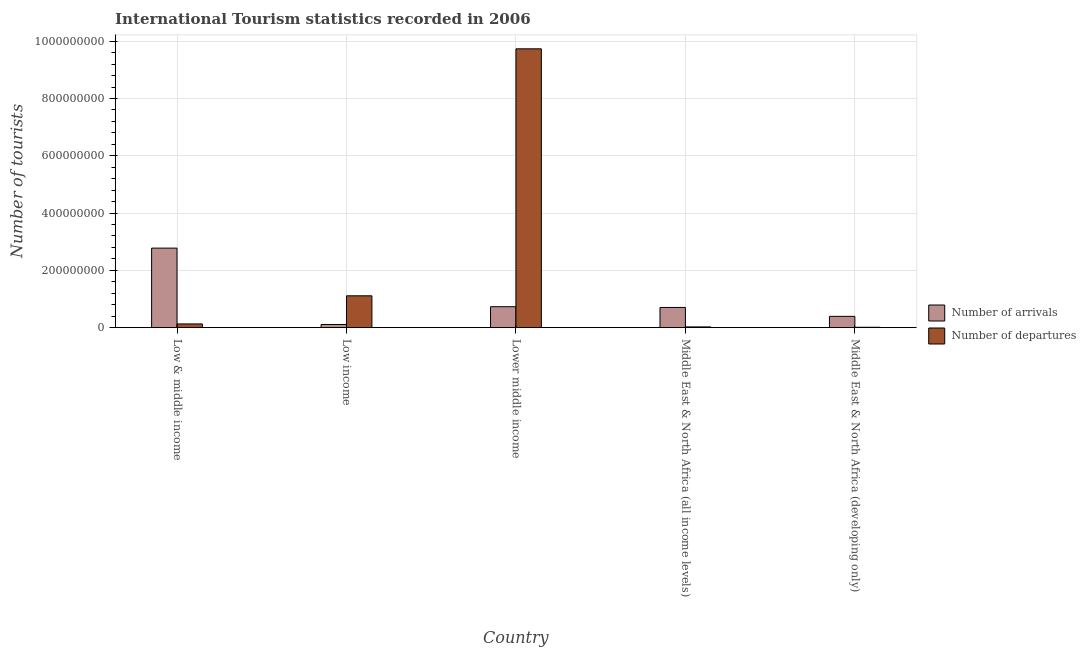Are the number of bars per tick equal to the number of legend labels?
Provide a succinct answer. Yes. What is the label of the 4th group of bars from the left?
Make the answer very short. Middle East & North Africa (all income levels). What is the number of tourist arrivals in Middle East & North Africa (all income levels)?
Offer a terse response. 7.06e+07. Across all countries, what is the maximum number of tourist departures?
Keep it short and to the point. 9.73e+08. Across all countries, what is the minimum number of tourist departures?
Provide a succinct answer. 1.35e+06. In which country was the number of tourist departures maximum?
Your answer should be very brief. Lower middle income. In which country was the number of tourist departures minimum?
Provide a short and direct response. Middle East & North Africa (developing only). What is the total number of tourist arrivals in the graph?
Provide a succinct answer. 4.72e+08. What is the difference between the number of tourist arrivals in Low income and that in Lower middle income?
Provide a succinct answer. -6.20e+07. What is the difference between the number of tourist departures in Low income and the number of tourist arrivals in Middle East & North Africa (developing only)?
Provide a succinct answer. 7.17e+07. What is the average number of tourist departures per country?
Your response must be concise. 2.20e+08. What is the difference between the number of tourist departures and number of tourist arrivals in Low income?
Provide a short and direct response. 1.00e+08. What is the ratio of the number of tourist arrivals in Low income to that in Middle East & North Africa (developing only)?
Offer a terse response. 0.28. Is the number of tourist arrivals in Lower middle income less than that in Middle East & North Africa (developing only)?
Ensure brevity in your answer.  No. What is the difference between the highest and the second highest number of tourist departures?
Offer a terse response. 8.62e+08. What is the difference between the highest and the lowest number of tourist arrivals?
Keep it short and to the point. 2.67e+08. In how many countries, is the number of tourist arrivals greater than the average number of tourist arrivals taken over all countries?
Offer a terse response. 1. Is the sum of the number of tourist departures in Low & middle income and Lower middle income greater than the maximum number of tourist arrivals across all countries?
Give a very brief answer. Yes. What does the 2nd bar from the left in Lower middle income represents?
Your response must be concise. Number of departures. What does the 1st bar from the right in Lower middle income represents?
Ensure brevity in your answer.  Number of departures. How many bars are there?
Your answer should be compact. 10. Are the values on the major ticks of Y-axis written in scientific E-notation?
Provide a short and direct response. No. Does the graph contain any zero values?
Your response must be concise. No. Does the graph contain grids?
Offer a terse response. Yes. Where does the legend appear in the graph?
Keep it short and to the point. Center right. How are the legend labels stacked?
Provide a short and direct response. Vertical. What is the title of the graph?
Your answer should be very brief. International Tourism statistics recorded in 2006. Does "Revenue" appear as one of the legend labels in the graph?
Offer a terse response. No. What is the label or title of the Y-axis?
Your answer should be compact. Number of tourists. What is the Number of tourists of Number of arrivals in Low & middle income?
Give a very brief answer. 2.78e+08. What is the Number of tourists in Number of departures in Low & middle income?
Keep it short and to the point. 1.30e+07. What is the Number of tourists of Number of arrivals in Low income?
Ensure brevity in your answer.  1.11e+07. What is the Number of tourists of Number of departures in Low income?
Offer a very short reply. 1.11e+08. What is the Number of tourists of Number of arrivals in Lower middle income?
Give a very brief answer. 7.31e+07. What is the Number of tourists of Number of departures in Lower middle income?
Ensure brevity in your answer.  9.73e+08. What is the Number of tourists in Number of arrivals in Middle East & North Africa (all income levels)?
Your answer should be very brief. 7.06e+07. What is the Number of tourists of Number of departures in Middle East & North Africa (all income levels)?
Make the answer very short. 2.62e+06. What is the Number of tourists of Number of arrivals in Middle East & North Africa (developing only)?
Make the answer very short. 3.95e+07. What is the Number of tourists of Number of departures in Middle East & North Africa (developing only)?
Provide a succinct answer. 1.35e+06. Across all countries, what is the maximum Number of tourists in Number of arrivals?
Make the answer very short. 2.78e+08. Across all countries, what is the maximum Number of tourists in Number of departures?
Ensure brevity in your answer.  9.73e+08. Across all countries, what is the minimum Number of tourists in Number of arrivals?
Keep it short and to the point. 1.11e+07. Across all countries, what is the minimum Number of tourists in Number of departures?
Ensure brevity in your answer.  1.35e+06. What is the total Number of tourists in Number of arrivals in the graph?
Your response must be concise. 4.72e+08. What is the total Number of tourists of Number of departures in the graph?
Your answer should be compact. 1.10e+09. What is the difference between the Number of tourists in Number of arrivals in Low & middle income and that in Low income?
Your response must be concise. 2.67e+08. What is the difference between the Number of tourists of Number of departures in Low & middle income and that in Low income?
Provide a short and direct response. -9.82e+07. What is the difference between the Number of tourists of Number of arrivals in Low & middle income and that in Lower middle income?
Your answer should be very brief. 2.05e+08. What is the difference between the Number of tourists in Number of departures in Low & middle income and that in Lower middle income?
Provide a succinct answer. -9.60e+08. What is the difference between the Number of tourists in Number of arrivals in Low & middle income and that in Middle East & North Africa (all income levels)?
Make the answer very short. 2.07e+08. What is the difference between the Number of tourists of Number of departures in Low & middle income and that in Middle East & North Africa (all income levels)?
Keep it short and to the point. 1.04e+07. What is the difference between the Number of tourists in Number of arrivals in Low & middle income and that in Middle East & North Africa (developing only)?
Provide a succinct answer. 2.38e+08. What is the difference between the Number of tourists of Number of departures in Low & middle income and that in Middle East & North Africa (developing only)?
Provide a succinct answer. 1.17e+07. What is the difference between the Number of tourists in Number of arrivals in Low income and that in Lower middle income?
Offer a terse response. -6.20e+07. What is the difference between the Number of tourists in Number of departures in Low income and that in Lower middle income?
Give a very brief answer. -8.62e+08. What is the difference between the Number of tourists in Number of arrivals in Low income and that in Middle East & North Africa (all income levels)?
Offer a very short reply. -5.94e+07. What is the difference between the Number of tourists of Number of departures in Low income and that in Middle East & North Africa (all income levels)?
Ensure brevity in your answer.  1.09e+08. What is the difference between the Number of tourists of Number of arrivals in Low income and that in Middle East & North Africa (developing only)?
Offer a terse response. -2.84e+07. What is the difference between the Number of tourists of Number of departures in Low income and that in Middle East & North Africa (developing only)?
Ensure brevity in your answer.  1.10e+08. What is the difference between the Number of tourists of Number of arrivals in Lower middle income and that in Middle East & North Africa (all income levels)?
Provide a succinct answer. 2.56e+06. What is the difference between the Number of tourists in Number of departures in Lower middle income and that in Middle East & North Africa (all income levels)?
Offer a very short reply. 9.71e+08. What is the difference between the Number of tourists of Number of arrivals in Lower middle income and that in Middle East & North Africa (developing only)?
Your answer should be compact. 3.36e+07. What is the difference between the Number of tourists in Number of departures in Lower middle income and that in Middle East & North Africa (developing only)?
Make the answer very short. 9.72e+08. What is the difference between the Number of tourists in Number of arrivals in Middle East & North Africa (all income levels) and that in Middle East & North Africa (developing only)?
Keep it short and to the point. 3.11e+07. What is the difference between the Number of tourists of Number of departures in Middle East & North Africa (all income levels) and that in Middle East & North Africa (developing only)?
Keep it short and to the point. 1.27e+06. What is the difference between the Number of tourists of Number of arrivals in Low & middle income and the Number of tourists of Number of departures in Low income?
Your response must be concise. 1.66e+08. What is the difference between the Number of tourists in Number of arrivals in Low & middle income and the Number of tourists in Number of departures in Lower middle income?
Provide a short and direct response. -6.96e+08. What is the difference between the Number of tourists of Number of arrivals in Low & middle income and the Number of tourists of Number of departures in Middle East & North Africa (all income levels)?
Provide a succinct answer. 2.75e+08. What is the difference between the Number of tourists of Number of arrivals in Low & middle income and the Number of tourists of Number of departures in Middle East & North Africa (developing only)?
Your answer should be compact. 2.76e+08. What is the difference between the Number of tourists in Number of arrivals in Low income and the Number of tourists in Number of departures in Lower middle income?
Give a very brief answer. -9.62e+08. What is the difference between the Number of tourists in Number of arrivals in Low income and the Number of tourists in Number of departures in Middle East & North Africa (all income levels)?
Provide a succinct answer. 8.51e+06. What is the difference between the Number of tourists of Number of arrivals in Low income and the Number of tourists of Number of departures in Middle East & North Africa (developing only)?
Your answer should be compact. 9.78e+06. What is the difference between the Number of tourists in Number of arrivals in Lower middle income and the Number of tourists in Number of departures in Middle East & North Africa (all income levels)?
Provide a succinct answer. 7.05e+07. What is the difference between the Number of tourists of Number of arrivals in Lower middle income and the Number of tourists of Number of departures in Middle East & North Africa (developing only)?
Your answer should be very brief. 7.18e+07. What is the difference between the Number of tourists of Number of arrivals in Middle East & North Africa (all income levels) and the Number of tourists of Number of departures in Middle East & North Africa (developing only)?
Keep it short and to the point. 6.92e+07. What is the average Number of tourists in Number of arrivals per country?
Make the answer very short. 9.44e+07. What is the average Number of tourists in Number of departures per country?
Provide a short and direct response. 2.20e+08. What is the difference between the Number of tourists in Number of arrivals and Number of tourists in Number of departures in Low & middle income?
Your answer should be compact. 2.65e+08. What is the difference between the Number of tourists of Number of arrivals and Number of tourists of Number of departures in Low income?
Make the answer very short. -1.00e+08. What is the difference between the Number of tourists of Number of arrivals and Number of tourists of Number of departures in Lower middle income?
Provide a succinct answer. -9.00e+08. What is the difference between the Number of tourists of Number of arrivals and Number of tourists of Number of departures in Middle East & North Africa (all income levels)?
Your response must be concise. 6.80e+07. What is the difference between the Number of tourists in Number of arrivals and Number of tourists in Number of departures in Middle East & North Africa (developing only)?
Your answer should be compact. 3.82e+07. What is the ratio of the Number of tourists in Number of arrivals in Low & middle income to that in Low income?
Provide a succinct answer. 24.94. What is the ratio of the Number of tourists of Number of departures in Low & middle income to that in Low income?
Your response must be concise. 0.12. What is the ratio of the Number of tourists of Number of arrivals in Low & middle income to that in Lower middle income?
Your response must be concise. 3.8. What is the ratio of the Number of tourists of Number of departures in Low & middle income to that in Lower middle income?
Your answer should be compact. 0.01. What is the ratio of the Number of tourists of Number of arrivals in Low & middle income to that in Middle East & North Africa (all income levels)?
Your answer should be very brief. 3.93. What is the ratio of the Number of tourists of Number of departures in Low & middle income to that in Middle East & North Africa (all income levels)?
Your response must be concise. 4.98. What is the ratio of the Number of tourists of Number of arrivals in Low & middle income to that in Middle East & North Africa (developing only)?
Your response must be concise. 7.03. What is the ratio of the Number of tourists of Number of departures in Low & middle income to that in Middle East & North Africa (developing only)?
Ensure brevity in your answer.  9.66. What is the ratio of the Number of tourists in Number of arrivals in Low income to that in Lower middle income?
Give a very brief answer. 0.15. What is the ratio of the Number of tourists of Number of departures in Low income to that in Lower middle income?
Your answer should be very brief. 0.11. What is the ratio of the Number of tourists of Number of arrivals in Low income to that in Middle East & North Africa (all income levels)?
Your response must be concise. 0.16. What is the ratio of the Number of tourists of Number of departures in Low income to that in Middle East & North Africa (all income levels)?
Your answer should be compact. 42.5. What is the ratio of the Number of tourists in Number of arrivals in Low income to that in Middle East & North Africa (developing only)?
Your answer should be compact. 0.28. What is the ratio of the Number of tourists in Number of departures in Low income to that in Middle East & North Africa (developing only)?
Provide a short and direct response. 82.43. What is the ratio of the Number of tourists in Number of arrivals in Lower middle income to that in Middle East & North Africa (all income levels)?
Provide a succinct answer. 1.04. What is the ratio of the Number of tourists of Number of departures in Lower middle income to that in Middle East & North Africa (all income levels)?
Your answer should be very brief. 372.08. What is the ratio of the Number of tourists of Number of arrivals in Lower middle income to that in Middle East & North Africa (developing only)?
Offer a very short reply. 1.85. What is the ratio of the Number of tourists in Number of departures in Lower middle income to that in Middle East & North Africa (developing only)?
Provide a short and direct response. 721.54. What is the ratio of the Number of tourists in Number of arrivals in Middle East & North Africa (all income levels) to that in Middle East & North Africa (developing only)?
Provide a succinct answer. 1.79. What is the ratio of the Number of tourists in Number of departures in Middle East & North Africa (all income levels) to that in Middle East & North Africa (developing only)?
Give a very brief answer. 1.94. What is the difference between the highest and the second highest Number of tourists in Number of arrivals?
Your response must be concise. 2.05e+08. What is the difference between the highest and the second highest Number of tourists of Number of departures?
Keep it short and to the point. 8.62e+08. What is the difference between the highest and the lowest Number of tourists in Number of arrivals?
Offer a very short reply. 2.67e+08. What is the difference between the highest and the lowest Number of tourists of Number of departures?
Ensure brevity in your answer.  9.72e+08. 